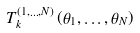<formula> <loc_0><loc_0><loc_500><loc_500>T ^ { ( 1 , \dots , N ) } _ { k } \left ( \theta _ { 1 } , \dots , \theta _ { N } \right )</formula> 